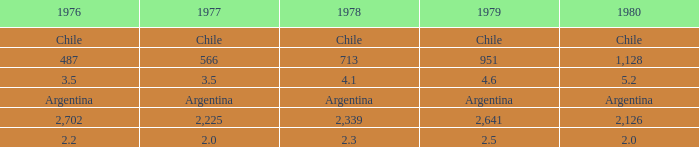3? 2.0. 